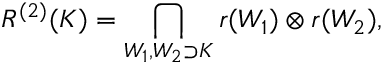Convert formula to latex. <formula><loc_0><loc_0><loc_500><loc_500>R ^ { ( 2 ) } ( K ) = \bigcap _ { W _ { 1 } , W _ { 2 } \supset K } r ( W _ { 1 } ) \otimes r ( W _ { 2 } ) ,</formula> 